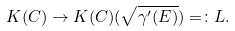Convert formula to latex. <formula><loc_0><loc_0><loc_500><loc_500>K ( C ) \rightarrow { K ( C ) ( \sqrt { \gamma ^ { \prime } ( E ) } ) } = \colon L .</formula> 